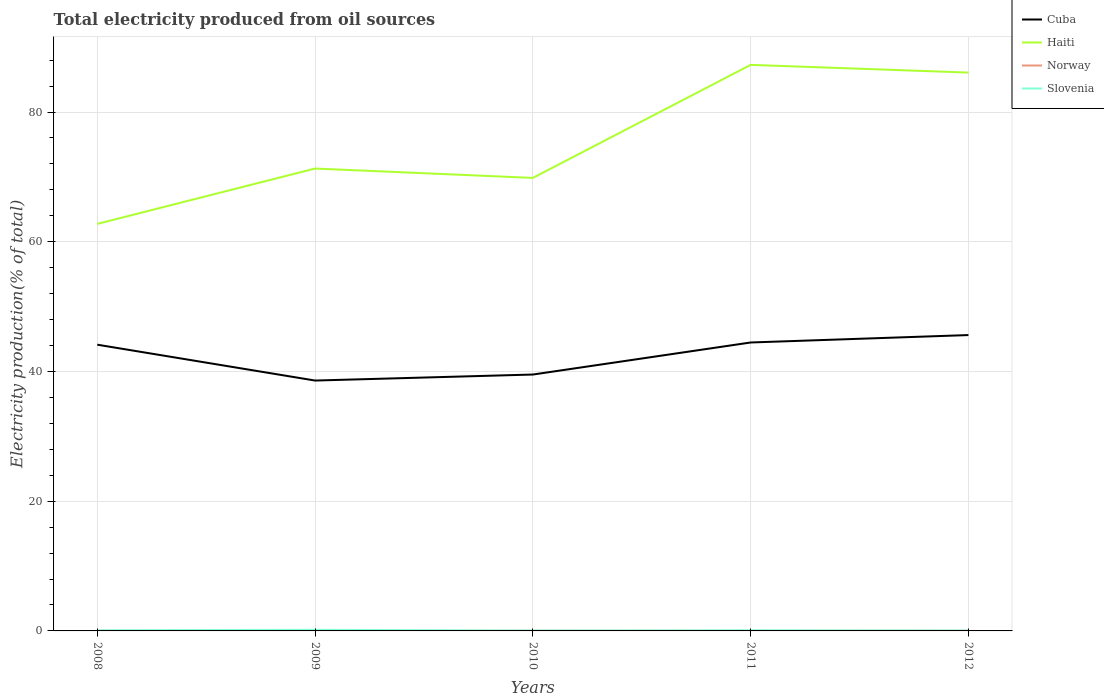How many different coloured lines are there?
Provide a succinct answer. 4. Does the line corresponding to Haiti intersect with the line corresponding to Slovenia?
Your answer should be very brief. No. Is the number of lines equal to the number of legend labels?
Provide a short and direct response. Yes. Across all years, what is the maximum total electricity produced in Slovenia?
Make the answer very short. 0.05. What is the total total electricity produced in Haiti in the graph?
Ensure brevity in your answer.  1.44. What is the difference between the highest and the second highest total electricity produced in Cuba?
Your answer should be compact. 7.01. What is the difference between the highest and the lowest total electricity produced in Norway?
Give a very brief answer. 2. How many years are there in the graph?
Your answer should be compact. 5. What is the difference between two consecutive major ticks on the Y-axis?
Keep it short and to the point. 20. Does the graph contain grids?
Your answer should be compact. Yes. How many legend labels are there?
Ensure brevity in your answer.  4. How are the legend labels stacked?
Ensure brevity in your answer.  Vertical. What is the title of the graph?
Ensure brevity in your answer.  Total electricity produced from oil sources. What is the label or title of the Y-axis?
Your answer should be compact. Electricity production(% of total). What is the Electricity production(% of total) in Cuba in 2008?
Keep it short and to the point. 44.13. What is the Electricity production(% of total) of Haiti in 2008?
Offer a very short reply. 62.76. What is the Electricity production(% of total) of Norway in 2008?
Ensure brevity in your answer.  0.02. What is the Electricity production(% of total) in Slovenia in 2008?
Ensure brevity in your answer.  0.1. What is the Electricity production(% of total) in Cuba in 2009?
Provide a succinct answer. 38.6. What is the Electricity production(% of total) in Haiti in 2009?
Provide a short and direct response. 71.29. What is the Electricity production(% of total) of Norway in 2009?
Ensure brevity in your answer.  0.02. What is the Electricity production(% of total) in Slovenia in 2009?
Provide a succinct answer. 0.17. What is the Electricity production(% of total) of Cuba in 2010?
Ensure brevity in your answer.  39.53. What is the Electricity production(% of total) of Haiti in 2010?
Your answer should be compact. 69.85. What is the Electricity production(% of total) in Norway in 2010?
Make the answer very short. 0.03. What is the Electricity production(% of total) of Slovenia in 2010?
Your answer should be compact. 0.05. What is the Electricity production(% of total) in Cuba in 2011?
Your response must be concise. 44.47. What is the Electricity production(% of total) of Haiti in 2011?
Keep it short and to the point. 87.27. What is the Electricity production(% of total) of Norway in 2011?
Your response must be concise. 0.02. What is the Electricity production(% of total) of Slovenia in 2011?
Provide a short and direct response. 0.1. What is the Electricity production(% of total) in Cuba in 2012?
Your response must be concise. 45.62. What is the Electricity production(% of total) of Haiti in 2012?
Offer a very short reply. 86.09. What is the Electricity production(% of total) of Norway in 2012?
Keep it short and to the point. 0.03. What is the Electricity production(% of total) in Slovenia in 2012?
Provide a short and direct response. 0.06. Across all years, what is the maximum Electricity production(% of total) in Cuba?
Ensure brevity in your answer.  45.62. Across all years, what is the maximum Electricity production(% of total) of Haiti?
Ensure brevity in your answer.  87.27. Across all years, what is the maximum Electricity production(% of total) in Norway?
Provide a short and direct response. 0.03. Across all years, what is the maximum Electricity production(% of total) in Slovenia?
Make the answer very short. 0.17. Across all years, what is the minimum Electricity production(% of total) of Cuba?
Keep it short and to the point. 38.6. Across all years, what is the minimum Electricity production(% of total) in Haiti?
Offer a terse response. 62.76. Across all years, what is the minimum Electricity production(% of total) of Norway?
Your response must be concise. 0.02. Across all years, what is the minimum Electricity production(% of total) in Slovenia?
Your answer should be compact. 0.05. What is the total Electricity production(% of total) in Cuba in the graph?
Ensure brevity in your answer.  212.35. What is the total Electricity production(% of total) in Haiti in the graph?
Give a very brief answer. 377.26. What is the total Electricity production(% of total) of Norway in the graph?
Offer a terse response. 0.12. What is the total Electricity production(% of total) in Slovenia in the graph?
Ensure brevity in your answer.  0.48. What is the difference between the Electricity production(% of total) of Cuba in 2008 and that in 2009?
Make the answer very short. 5.53. What is the difference between the Electricity production(% of total) of Haiti in 2008 and that in 2009?
Your answer should be very brief. -8.53. What is the difference between the Electricity production(% of total) of Slovenia in 2008 and that in 2009?
Offer a terse response. -0.07. What is the difference between the Electricity production(% of total) of Cuba in 2008 and that in 2010?
Offer a terse response. 4.6. What is the difference between the Electricity production(% of total) in Haiti in 2008 and that in 2010?
Offer a terse response. -7.09. What is the difference between the Electricity production(% of total) of Norway in 2008 and that in 2010?
Provide a short and direct response. -0. What is the difference between the Electricity production(% of total) in Slovenia in 2008 and that in 2010?
Your response must be concise. 0.05. What is the difference between the Electricity production(% of total) in Cuba in 2008 and that in 2011?
Offer a very short reply. -0.34. What is the difference between the Electricity production(% of total) of Haiti in 2008 and that in 2011?
Ensure brevity in your answer.  -24.52. What is the difference between the Electricity production(% of total) of Norway in 2008 and that in 2011?
Make the answer very short. -0. What is the difference between the Electricity production(% of total) of Slovenia in 2008 and that in 2011?
Your answer should be very brief. -0. What is the difference between the Electricity production(% of total) of Cuba in 2008 and that in 2012?
Make the answer very short. -1.48. What is the difference between the Electricity production(% of total) in Haiti in 2008 and that in 2012?
Your answer should be compact. -23.33. What is the difference between the Electricity production(% of total) in Norway in 2008 and that in 2012?
Provide a succinct answer. -0.01. What is the difference between the Electricity production(% of total) of Slovenia in 2008 and that in 2012?
Offer a very short reply. 0.04. What is the difference between the Electricity production(% of total) of Cuba in 2009 and that in 2010?
Provide a short and direct response. -0.93. What is the difference between the Electricity production(% of total) in Haiti in 2009 and that in 2010?
Keep it short and to the point. 1.44. What is the difference between the Electricity production(% of total) in Norway in 2009 and that in 2010?
Make the answer very short. -0. What is the difference between the Electricity production(% of total) in Slovenia in 2009 and that in 2010?
Your answer should be very brief. 0.12. What is the difference between the Electricity production(% of total) in Cuba in 2009 and that in 2011?
Your answer should be compact. -5.87. What is the difference between the Electricity production(% of total) of Haiti in 2009 and that in 2011?
Ensure brevity in your answer.  -15.98. What is the difference between the Electricity production(% of total) of Norway in 2009 and that in 2011?
Provide a short and direct response. -0. What is the difference between the Electricity production(% of total) of Slovenia in 2009 and that in 2011?
Your answer should be very brief. 0.07. What is the difference between the Electricity production(% of total) of Cuba in 2009 and that in 2012?
Keep it short and to the point. -7.01. What is the difference between the Electricity production(% of total) of Haiti in 2009 and that in 2012?
Offer a very short reply. -14.8. What is the difference between the Electricity production(% of total) of Norway in 2009 and that in 2012?
Your answer should be very brief. -0.01. What is the difference between the Electricity production(% of total) of Slovenia in 2009 and that in 2012?
Ensure brevity in your answer.  0.11. What is the difference between the Electricity production(% of total) in Cuba in 2010 and that in 2011?
Keep it short and to the point. -4.94. What is the difference between the Electricity production(% of total) of Haiti in 2010 and that in 2011?
Provide a succinct answer. -17.43. What is the difference between the Electricity production(% of total) in Norway in 2010 and that in 2011?
Give a very brief answer. 0. What is the difference between the Electricity production(% of total) in Slovenia in 2010 and that in 2011?
Your answer should be very brief. -0.05. What is the difference between the Electricity production(% of total) of Cuba in 2010 and that in 2012?
Keep it short and to the point. -6.09. What is the difference between the Electricity production(% of total) of Haiti in 2010 and that in 2012?
Provide a short and direct response. -16.24. What is the difference between the Electricity production(% of total) in Norway in 2010 and that in 2012?
Give a very brief answer. -0. What is the difference between the Electricity production(% of total) of Slovenia in 2010 and that in 2012?
Your answer should be compact. -0.01. What is the difference between the Electricity production(% of total) of Cuba in 2011 and that in 2012?
Your response must be concise. -1.15. What is the difference between the Electricity production(% of total) in Haiti in 2011 and that in 2012?
Your response must be concise. 1.19. What is the difference between the Electricity production(% of total) of Norway in 2011 and that in 2012?
Ensure brevity in your answer.  -0. What is the difference between the Electricity production(% of total) of Slovenia in 2011 and that in 2012?
Offer a very short reply. 0.04. What is the difference between the Electricity production(% of total) of Cuba in 2008 and the Electricity production(% of total) of Haiti in 2009?
Keep it short and to the point. -27.16. What is the difference between the Electricity production(% of total) of Cuba in 2008 and the Electricity production(% of total) of Norway in 2009?
Keep it short and to the point. 44.11. What is the difference between the Electricity production(% of total) of Cuba in 2008 and the Electricity production(% of total) of Slovenia in 2009?
Make the answer very short. 43.96. What is the difference between the Electricity production(% of total) in Haiti in 2008 and the Electricity production(% of total) in Norway in 2009?
Offer a terse response. 62.73. What is the difference between the Electricity production(% of total) of Haiti in 2008 and the Electricity production(% of total) of Slovenia in 2009?
Ensure brevity in your answer.  62.59. What is the difference between the Electricity production(% of total) of Norway in 2008 and the Electricity production(% of total) of Slovenia in 2009?
Provide a succinct answer. -0.15. What is the difference between the Electricity production(% of total) of Cuba in 2008 and the Electricity production(% of total) of Haiti in 2010?
Your response must be concise. -25.72. What is the difference between the Electricity production(% of total) of Cuba in 2008 and the Electricity production(% of total) of Norway in 2010?
Offer a very short reply. 44.11. What is the difference between the Electricity production(% of total) of Cuba in 2008 and the Electricity production(% of total) of Slovenia in 2010?
Keep it short and to the point. 44.08. What is the difference between the Electricity production(% of total) of Haiti in 2008 and the Electricity production(% of total) of Norway in 2010?
Ensure brevity in your answer.  62.73. What is the difference between the Electricity production(% of total) of Haiti in 2008 and the Electricity production(% of total) of Slovenia in 2010?
Your answer should be compact. 62.71. What is the difference between the Electricity production(% of total) of Norway in 2008 and the Electricity production(% of total) of Slovenia in 2010?
Your response must be concise. -0.03. What is the difference between the Electricity production(% of total) of Cuba in 2008 and the Electricity production(% of total) of Haiti in 2011?
Provide a short and direct response. -43.14. What is the difference between the Electricity production(% of total) of Cuba in 2008 and the Electricity production(% of total) of Norway in 2011?
Give a very brief answer. 44.11. What is the difference between the Electricity production(% of total) in Cuba in 2008 and the Electricity production(% of total) in Slovenia in 2011?
Your answer should be compact. 44.03. What is the difference between the Electricity production(% of total) in Haiti in 2008 and the Electricity production(% of total) in Norway in 2011?
Provide a succinct answer. 62.73. What is the difference between the Electricity production(% of total) of Haiti in 2008 and the Electricity production(% of total) of Slovenia in 2011?
Give a very brief answer. 62.66. What is the difference between the Electricity production(% of total) in Norway in 2008 and the Electricity production(% of total) in Slovenia in 2011?
Keep it short and to the point. -0.08. What is the difference between the Electricity production(% of total) in Cuba in 2008 and the Electricity production(% of total) in Haiti in 2012?
Offer a terse response. -41.96. What is the difference between the Electricity production(% of total) of Cuba in 2008 and the Electricity production(% of total) of Norway in 2012?
Your response must be concise. 44.1. What is the difference between the Electricity production(% of total) in Cuba in 2008 and the Electricity production(% of total) in Slovenia in 2012?
Keep it short and to the point. 44.07. What is the difference between the Electricity production(% of total) of Haiti in 2008 and the Electricity production(% of total) of Norway in 2012?
Your response must be concise. 62.73. What is the difference between the Electricity production(% of total) of Haiti in 2008 and the Electricity production(% of total) of Slovenia in 2012?
Your response must be concise. 62.7. What is the difference between the Electricity production(% of total) in Norway in 2008 and the Electricity production(% of total) in Slovenia in 2012?
Your answer should be very brief. -0.03. What is the difference between the Electricity production(% of total) in Cuba in 2009 and the Electricity production(% of total) in Haiti in 2010?
Keep it short and to the point. -31.24. What is the difference between the Electricity production(% of total) in Cuba in 2009 and the Electricity production(% of total) in Norway in 2010?
Your answer should be very brief. 38.58. What is the difference between the Electricity production(% of total) of Cuba in 2009 and the Electricity production(% of total) of Slovenia in 2010?
Your answer should be compact. 38.55. What is the difference between the Electricity production(% of total) of Haiti in 2009 and the Electricity production(% of total) of Norway in 2010?
Provide a succinct answer. 71.26. What is the difference between the Electricity production(% of total) of Haiti in 2009 and the Electricity production(% of total) of Slovenia in 2010?
Keep it short and to the point. 71.24. What is the difference between the Electricity production(% of total) in Norway in 2009 and the Electricity production(% of total) in Slovenia in 2010?
Your answer should be compact. -0.03. What is the difference between the Electricity production(% of total) in Cuba in 2009 and the Electricity production(% of total) in Haiti in 2011?
Provide a succinct answer. -48.67. What is the difference between the Electricity production(% of total) of Cuba in 2009 and the Electricity production(% of total) of Norway in 2011?
Make the answer very short. 38.58. What is the difference between the Electricity production(% of total) of Cuba in 2009 and the Electricity production(% of total) of Slovenia in 2011?
Provide a succinct answer. 38.5. What is the difference between the Electricity production(% of total) in Haiti in 2009 and the Electricity production(% of total) in Norway in 2011?
Make the answer very short. 71.27. What is the difference between the Electricity production(% of total) of Haiti in 2009 and the Electricity production(% of total) of Slovenia in 2011?
Your answer should be very brief. 71.19. What is the difference between the Electricity production(% of total) in Norway in 2009 and the Electricity production(% of total) in Slovenia in 2011?
Make the answer very short. -0.08. What is the difference between the Electricity production(% of total) of Cuba in 2009 and the Electricity production(% of total) of Haiti in 2012?
Provide a succinct answer. -47.48. What is the difference between the Electricity production(% of total) of Cuba in 2009 and the Electricity production(% of total) of Norway in 2012?
Your response must be concise. 38.58. What is the difference between the Electricity production(% of total) of Cuba in 2009 and the Electricity production(% of total) of Slovenia in 2012?
Ensure brevity in your answer.  38.55. What is the difference between the Electricity production(% of total) of Haiti in 2009 and the Electricity production(% of total) of Norway in 2012?
Your answer should be very brief. 71.26. What is the difference between the Electricity production(% of total) of Haiti in 2009 and the Electricity production(% of total) of Slovenia in 2012?
Your answer should be compact. 71.23. What is the difference between the Electricity production(% of total) in Norway in 2009 and the Electricity production(% of total) in Slovenia in 2012?
Provide a short and direct response. -0.04. What is the difference between the Electricity production(% of total) of Cuba in 2010 and the Electricity production(% of total) of Haiti in 2011?
Provide a short and direct response. -47.74. What is the difference between the Electricity production(% of total) of Cuba in 2010 and the Electricity production(% of total) of Norway in 2011?
Your answer should be very brief. 39.51. What is the difference between the Electricity production(% of total) of Cuba in 2010 and the Electricity production(% of total) of Slovenia in 2011?
Provide a short and direct response. 39.43. What is the difference between the Electricity production(% of total) in Haiti in 2010 and the Electricity production(% of total) in Norway in 2011?
Provide a short and direct response. 69.82. What is the difference between the Electricity production(% of total) of Haiti in 2010 and the Electricity production(% of total) of Slovenia in 2011?
Your answer should be compact. 69.75. What is the difference between the Electricity production(% of total) in Norway in 2010 and the Electricity production(% of total) in Slovenia in 2011?
Make the answer very short. -0.08. What is the difference between the Electricity production(% of total) in Cuba in 2010 and the Electricity production(% of total) in Haiti in 2012?
Your answer should be very brief. -46.56. What is the difference between the Electricity production(% of total) in Cuba in 2010 and the Electricity production(% of total) in Norway in 2012?
Give a very brief answer. 39.5. What is the difference between the Electricity production(% of total) of Cuba in 2010 and the Electricity production(% of total) of Slovenia in 2012?
Provide a succinct answer. 39.47. What is the difference between the Electricity production(% of total) of Haiti in 2010 and the Electricity production(% of total) of Norway in 2012?
Give a very brief answer. 69.82. What is the difference between the Electricity production(% of total) in Haiti in 2010 and the Electricity production(% of total) in Slovenia in 2012?
Offer a terse response. 69.79. What is the difference between the Electricity production(% of total) in Norway in 2010 and the Electricity production(% of total) in Slovenia in 2012?
Keep it short and to the point. -0.03. What is the difference between the Electricity production(% of total) in Cuba in 2011 and the Electricity production(% of total) in Haiti in 2012?
Make the answer very short. -41.62. What is the difference between the Electricity production(% of total) of Cuba in 2011 and the Electricity production(% of total) of Norway in 2012?
Give a very brief answer. 44.44. What is the difference between the Electricity production(% of total) in Cuba in 2011 and the Electricity production(% of total) in Slovenia in 2012?
Keep it short and to the point. 44.41. What is the difference between the Electricity production(% of total) of Haiti in 2011 and the Electricity production(% of total) of Norway in 2012?
Offer a very short reply. 87.25. What is the difference between the Electricity production(% of total) of Haiti in 2011 and the Electricity production(% of total) of Slovenia in 2012?
Offer a very short reply. 87.22. What is the difference between the Electricity production(% of total) in Norway in 2011 and the Electricity production(% of total) in Slovenia in 2012?
Your answer should be compact. -0.03. What is the average Electricity production(% of total) of Cuba per year?
Offer a very short reply. 42.47. What is the average Electricity production(% of total) in Haiti per year?
Offer a very short reply. 75.45. What is the average Electricity production(% of total) of Norway per year?
Your answer should be compact. 0.02. What is the average Electricity production(% of total) in Slovenia per year?
Provide a succinct answer. 0.1. In the year 2008, what is the difference between the Electricity production(% of total) in Cuba and Electricity production(% of total) in Haiti?
Provide a short and direct response. -18.63. In the year 2008, what is the difference between the Electricity production(% of total) in Cuba and Electricity production(% of total) in Norway?
Your answer should be very brief. 44.11. In the year 2008, what is the difference between the Electricity production(% of total) of Cuba and Electricity production(% of total) of Slovenia?
Give a very brief answer. 44.03. In the year 2008, what is the difference between the Electricity production(% of total) of Haiti and Electricity production(% of total) of Norway?
Your response must be concise. 62.73. In the year 2008, what is the difference between the Electricity production(% of total) in Haiti and Electricity production(% of total) in Slovenia?
Keep it short and to the point. 62.66. In the year 2008, what is the difference between the Electricity production(% of total) of Norway and Electricity production(% of total) of Slovenia?
Your answer should be compact. -0.07. In the year 2009, what is the difference between the Electricity production(% of total) of Cuba and Electricity production(% of total) of Haiti?
Make the answer very short. -32.69. In the year 2009, what is the difference between the Electricity production(% of total) in Cuba and Electricity production(% of total) in Norway?
Your answer should be very brief. 38.58. In the year 2009, what is the difference between the Electricity production(% of total) of Cuba and Electricity production(% of total) of Slovenia?
Give a very brief answer. 38.43. In the year 2009, what is the difference between the Electricity production(% of total) of Haiti and Electricity production(% of total) of Norway?
Provide a short and direct response. 71.27. In the year 2009, what is the difference between the Electricity production(% of total) in Haiti and Electricity production(% of total) in Slovenia?
Offer a terse response. 71.12. In the year 2009, what is the difference between the Electricity production(% of total) in Norway and Electricity production(% of total) in Slovenia?
Make the answer very short. -0.15. In the year 2010, what is the difference between the Electricity production(% of total) in Cuba and Electricity production(% of total) in Haiti?
Offer a very short reply. -30.32. In the year 2010, what is the difference between the Electricity production(% of total) of Cuba and Electricity production(% of total) of Norway?
Provide a short and direct response. 39.5. In the year 2010, what is the difference between the Electricity production(% of total) in Cuba and Electricity production(% of total) in Slovenia?
Offer a very short reply. 39.48. In the year 2010, what is the difference between the Electricity production(% of total) in Haiti and Electricity production(% of total) in Norway?
Ensure brevity in your answer.  69.82. In the year 2010, what is the difference between the Electricity production(% of total) in Haiti and Electricity production(% of total) in Slovenia?
Ensure brevity in your answer.  69.8. In the year 2010, what is the difference between the Electricity production(% of total) in Norway and Electricity production(% of total) in Slovenia?
Give a very brief answer. -0.02. In the year 2011, what is the difference between the Electricity production(% of total) of Cuba and Electricity production(% of total) of Haiti?
Ensure brevity in your answer.  -42.8. In the year 2011, what is the difference between the Electricity production(% of total) in Cuba and Electricity production(% of total) in Norway?
Offer a very short reply. 44.45. In the year 2011, what is the difference between the Electricity production(% of total) of Cuba and Electricity production(% of total) of Slovenia?
Provide a short and direct response. 44.37. In the year 2011, what is the difference between the Electricity production(% of total) in Haiti and Electricity production(% of total) in Norway?
Provide a short and direct response. 87.25. In the year 2011, what is the difference between the Electricity production(% of total) in Haiti and Electricity production(% of total) in Slovenia?
Your response must be concise. 87.17. In the year 2011, what is the difference between the Electricity production(% of total) of Norway and Electricity production(% of total) of Slovenia?
Offer a terse response. -0.08. In the year 2012, what is the difference between the Electricity production(% of total) in Cuba and Electricity production(% of total) in Haiti?
Your answer should be very brief. -40.47. In the year 2012, what is the difference between the Electricity production(% of total) in Cuba and Electricity production(% of total) in Norway?
Your response must be concise. 45.59. In the year 2012, what is the difference between the Electricity production(% of total) of Cuba and Electricity production(% of total) of Slovenia?
Offer a very short reply. 45.56. In the year 2012, what is the difference between the Electricity production(% of total) in Haiti and Electricity production(% of total) in Norway?
Make the answer very short. 86.06. In the year 2012, what is the difference between the Electricity production(% of total) in Haiti and Electricity production(% of total) in Slovenia?
Provide a short and direct response. 86.03. In the year 2012, what is the difference between the Electricity production(% of total) in Norway and Electricity production(% of total) in Slovenia?
Provide a short and direct response. -0.03. What is the ratio of the Electricity production(% of total) of Cuba in 2008 to that in 2009?
Keep it short and to the point. 1.14. What is the ratio of the Electricity production(% of total) of Haiti in 2008 to that in 2009?
Offer a terse response. 0.88. What is the ratio of the Electricity production(% of total) of Norway in 2008 to that in 2009?
Offer a terse response. 1.02. What is the ratio of the Electricity production(% of total) of Slovenia in 2008 to that in 2009?
Offer a very short reply. 0.57. What is the ratio of the Electricity production(% of total) of Cuba in 2008 to that in 2010?
Your answer should be compact. 1.12. What is the ratio of the Electricity production(% of total) of Haiti in 2008 to that in 2010?
Ensure brevity in your answer.  0.9. What is the ratio of the Electricity production(% of total) of Norway in 2008 to that in 2010?
Keep it short and to the point. 0.93. What is the ratio of the Electricity production(% of total) of Slovenia in 2008 to that in 2010?
Offer a terse response. 1.98. What is the ratio of the Electricity production(% of total) in Haiti in 2008 to that in 2011?
Keep it short and to the point. 0.72. What is the ratio of the Electricity production(% of total) of Norway in 2008 to that in 2011?
Offer a very short reply. 0.98. What is the ratio of the Electricity production(% of total) in Slovenia in 2008 to that in 2011?
Make the answer very short. 0.97. What is the ratio of the Electricity production(% of total) of Cuba in 2008 to that in 2012?
Give a very brief answer. 0.97. What is the ratio of the Electricity production(% of total) of Haiti in 2008 to that in 2012?
Give a very brief answer. 0.73. What is the ratio of the Electricity production(% of total) in Norway in 2008 to that in 2012?
Make the answer very short. 0.82. What is the ratio of the Electricity production(% of total) in Slovenia in 2008 to that in 2012?
Ensure brevity in your answer.  1.68. What is the ratio of the Electricity production(% of total) of Cuba in 2009 to that in 2010?
Ensure brevity in your answer.  0.98. What is the ratio of the Electricity production(% of total) in Haiti in 2009 to that in 2010?
Your answer should be compact. 1.02. What is the ratio of the Electricity production(% of total) in Norway in 2009 to that in 2010?
Your response must be concise. 0.91. What is the ratio of the Electricity production(% of total) in Slovenia in 2009 to that in 2010?
Your answer should be very brief. 3.47. What is the ratio of the Electricity production(% of total) in Cuba in 2009 to that in 2011?
Ensure brevity in your answer.  0.87. What is the ratio of the Electricity production(% of total) in Haiti in 2009 to that in 2011?
Keep it short and to the point. 0.82. What is the ratio of the Electricity production(% of total) of Norway in 2009 to that in 2011?
Keep it short and to the point. 0.96. What is the ratio of the Electricity production(% of total) of Slovenia in 2009 to that in 2011?
Offer a terse response. 1.7. What is the ratio of the Electricity production(% of total) in Cuba in 2009 to that in 2012?
Ensure brevity in your answer.  0.85. What is the ratio of the Electricity production(% of total) in Haiti in 2009 to that in 2012?
Your response must be concise. 0.83. What is the ratio of the Electricity production(% of total) in Norway in 2009 to that in 2012?
Ensure brevity in your answer.  0.8. What is the ratio of the Electricity production(% of total) in Slovenia in 2009 to that in 2012?
Your answer should be compact. 2.95. What is the ratio of the Electricity production(% of total) of Cuba in 2010 to that in 2011?
Provide a succinct answer. 0.89. What is the ratio of the Electricity production(% of total) of Haiti in 2010 to that in 2011?
Your response must be concise. 0.8. What is the ratio of the Electricity production(% of total) in Norway in 2010 to that in 2011?
Your answer should be very brief. 1.06. What is the ratio of the Electricity production(% of total) in Slovenia in 2010 to that in 2011?
Provide a short and direct response. 0.49. What is the ratio of the Electricity production(% of total) in Cuba in 2010 to that in 2012?
Offer a terse response. 0.87. What is the ratio of the Electricity production(% of total) in Haiti in 2010 to that in 2012?
Provide a short and direct response. 0.81. What is the ratio of the Electricity production(% of total) of Norway in 2010 to that in 2012?
Ensure brevity in your answer.  0.88. What is the ratio of the Electricity production(% of total) in Slovenia in 2010 to that in 2012?
Offer a very short reply. 0.85. What is the ratio of the Electricity production(% of total) in Cuba in 2011 to that in 2012?
Provide a succinct answer. 0.97. What is the ratio of the Electricity production(% of total) of Haiti in 2011 to that in 2012?
Keep it short and to the point. 1.01. What is the ratio of the Electricity production(% of total) in Norway in 2011 to that in 2012?
Your answer should be compact. 0.83. What is the ratio of the Electricity production(% of total) of Slovenia in 2011 to that in 2012?
Give a very brief answer. 1.74. What is the difference between the highest and the second highest Electricity production(% of total) of Cuba?
Provide a short and direct response. 1.15. What is the difference between the highest and the second highest Electricity production(% of total) in Haiti?
Give a very brief answer. 1.19. What is the difference between the highest and the second highest Electricity production(% of total) of Norway?
Offer a terse response. 0. What is the difference between the highest and the second highest Electricity production(% of total) of Slovenia?
Offer a very short reply. 0.07. What is the difference between the highest and the lowest Electricity production(% of total) of Cuba?
Your answer should be very brief. 7.01. What is the difference between the highest and the lowest Electricity production(% of total) of Haiti?
Offer a very short reply. 24.52. What is the difference between the highest and the lowest Electricity production(% of total) of Norway?
Offer a terse response. 0.01. What is the difference between the highest and the lowest Electricity production(% of total) in Slovenia?
Give a very brief answer. 0.12. 